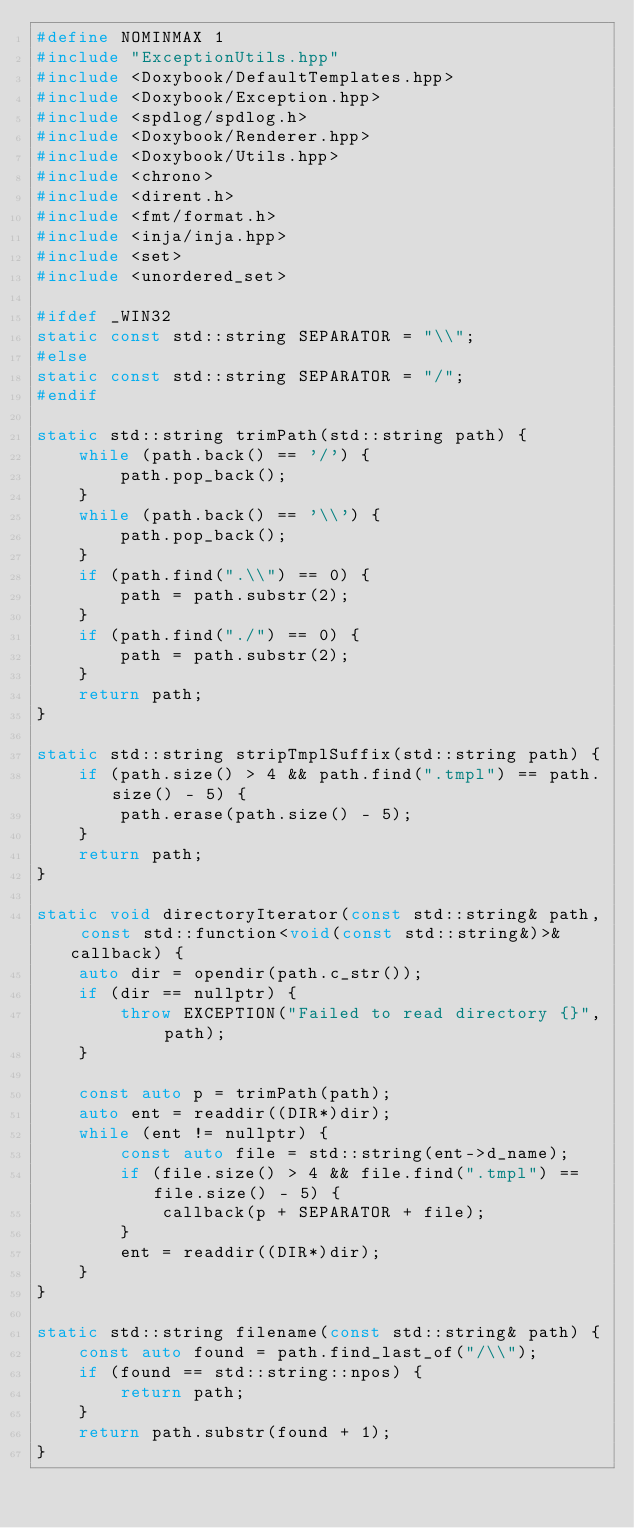Convert code to text. <code><loc_0><loc_0><loc_500><loc_500><_C++_>#define NOMINMAX 1
#include "ExceptionUtils.hpp"
#include <Doxybook/DefaultTemplates.hpp>
#include <Doxybook/Exception.hpp>
#include <spdlog/spdlog.h>
#include <Doxybook/Renderer.hpp>
#include <Doxybook/Utils.hpp>
#include <chrono>
#include <dirent.h>
#include <fmt/format.h>
#include <inja/inja.hpp>
#include <set>
#include <unordered_set>

#ifdef _WIN32
static const std::string SEPARATOR = "\\";
#else
static const std::string SEPARATOR = "/";
#endif

static std::string trimPath(std::string path) {
    while (path.back() == '/') {
        path.pop_back();
    }
    while (path.back() == '\\') {
        path.pop_back();
    }
    if (path.find(".\\") == 0) {
        path = path.substr(2);
    }
    if (path.find("./") == 0) {
        path = path.substr(2);
    }
    return path;
}

static std::string stripTmplSuffix(std::string path) {
    if (path.size() > 4 && path.find(".tmpl") == path.size() - 5) {
        path.erase(path.size() - 5);
    }
    return path;
}

static void directoryIterator(const std::string& path, const std::function<void(const std::string&)>& callback) {
    auto dir = opendir(path.c_str());
    if (dir == nullptr) {
        throw EXCEPTION("Failed to read directory {}", path);
    }

    const auto p = trimPath(path);
    auto ent = readdir((DIR*)dir);
    while (ent != nullptr) {
        const auto file = std::string(ent->d_name);
        if (file.size() > 4 && file.find(".tmpl") == file.size() - 5) {
            callback(p + SEPARATOR + file);
        }
        ent = readdir((DIR*)dir);
    }
}

static std::string filename(const std::string& path) {
    const auto found = path.find_last_of("/\\");
    if (found == std::string::npos) {
        return path;
    }
    return path.substr(found + 1);
}
</code> 